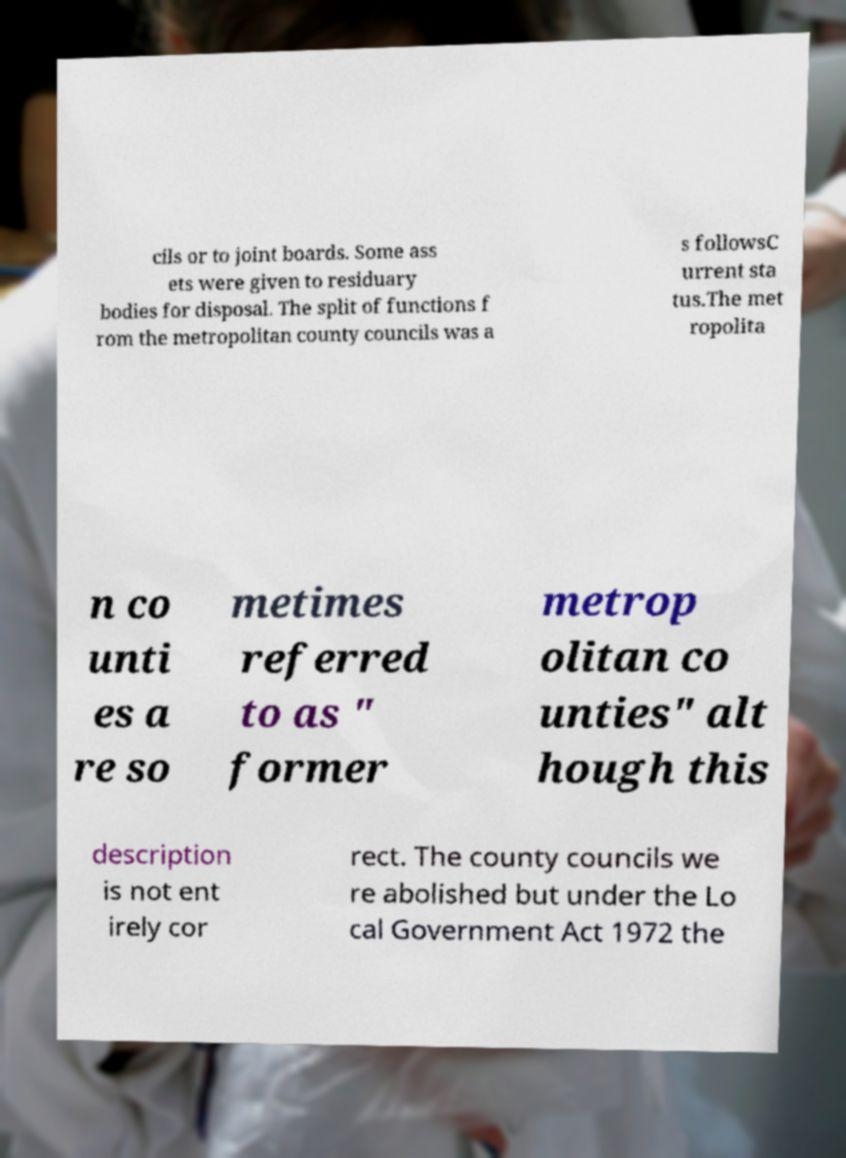I need the written content from this picture converted into text. Can you do that? cils or to joint boards. Some ass ets were given to residuary bodies for disposal. The split of functions f rom the metropolitan county councils was a s followsC urrent sta tus.The met ropolita n co unti es a re so metimes referred to as " former metrop olitan co unties" alt hough this description is not ent irely cor rect. The county councils we re abolished but under the Lo cal Government Act 1972 the 